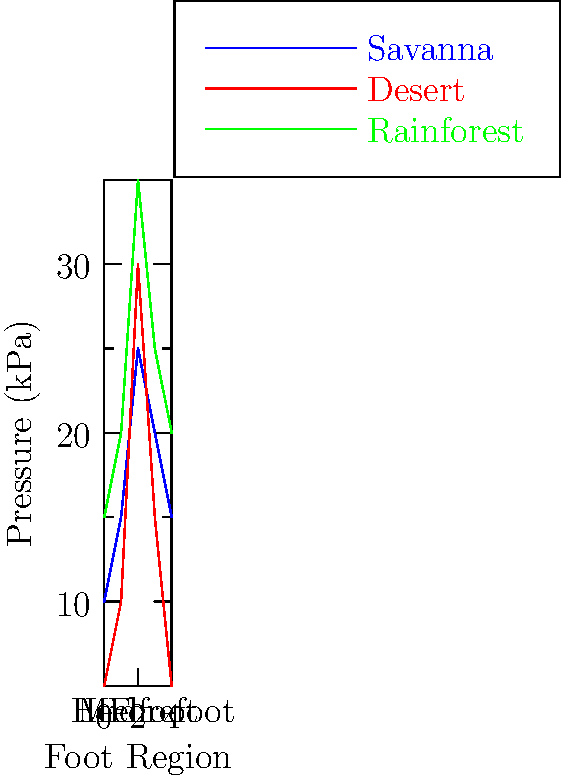Based on the foot pressure distribution patterns shown in the graph for different African terrains during barefoot walking, which terrain exhibits the highest peak pressure in the forefoot region? To determine which terrain exhibits the highest peak pressure in the forefoot region, we need to follow these steps:

1. Identify the forefoot region on the x-axis: The forefoot is typically represented by the third data point (x = 2) on the graph.

2. Compare the pressure values for each terrain at the forefoot point:
   - Savanna (blue line): Approximately 25 kPa
   - Desert (red line): Approximately 30 kPa
   - Rainforest (green line): Approximately 35 kPa

3. Identify the highest value among these three:
   The rainforest terrain shows the highest pressure at approximately 35 kPa.

4. Confirm that this is indeed the peak for the forefoot region:
   Looking at the surrounding points, we can see that the pressure values are lower on both sides of this peak for all terrains.

Therefore, the rainforest terrain exhibits the highest peak pressure in the forefoot region during barefoot walking.
Answer: Rainforest 